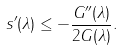Convert formula to latex. <formula><loc_0><loc_0><loc_500><loc_500>s ^ { \prime } ( \lambda ) \leq - \frac { G ^ { \prime \prime } ( \lambda ) } { 2 G ( \lambda ) } .</formula> 